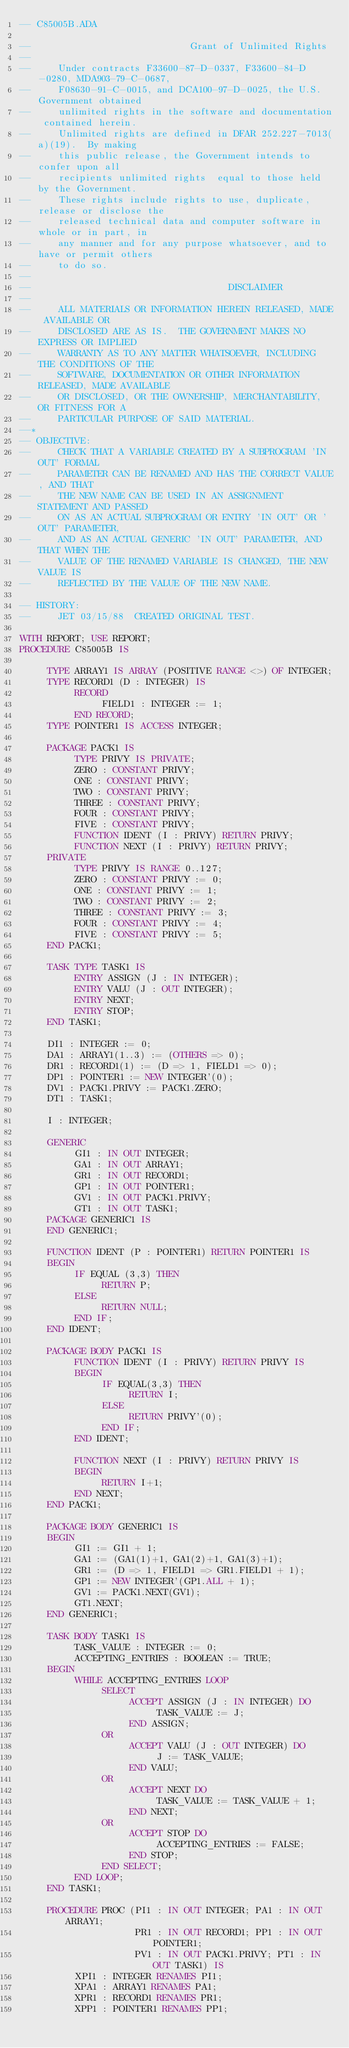Convert code to text. <code><loc_0><loc_0><loc_500><loc_500><_Ada_>-- C85005B.ADA

--                             Grant of Unlimited Rights
--
--     Under contracts F33600-87-D-0337, F33600-84-D-0280, MDA903-79-C-0687,
--     F08630-91-C-0015, and DCA100-97-D-0025, the U.S. Government obtained 
--     unlimited rights in the software and documentation contained herein.
--     Unlimited rights are defined in DFAR 252.227-7013(a)(19).  By making 
--     this public release, the Government intends to confer upon all 
--     recipients unlimited rights  equal to those held by the Government.  
--     These rights include rights to use, duplicate, release or disclose the 
--     released technical data and computer software in whole or in part, in 
--     any manner and for any purpose whatsoever, and to have or permit others 
--     to do so.
--
--                                    DISCLAIMER
--
--     ALL MATERIALS OR INFORMATION HEREIN RELEASED, MADE AVAILABLE OR
--     DISCLOSED ARE AS IS.  THE GOVERNMENT MAKES NO EXPRESS OR IMPLIED 
--     WARRANTY AS TO ANY MATTER WHATSOEVER, INCLUDING THE CONDITIONS OF THE
--     SOFTWARE, DOCUMENTATION OR OTHER INFORMATION RELEASED, MADE AVAILABLE 
--     OR DISCLOSED, OR THE OWNERSHIP, MERCHANTABILITY, OR FITNESS FOR A
--     PARTICULAR PURPOSE OF SAID MATERIAL.
--*
-- OBJECTIVE:
--     CHECK THAT A VARIABLE CREATED BY A SUBPROGRAM 'IN OUT' FORMAL
--     PARAMETER CAN BE RENAMED AND HAS THE CORRECT VALUE, AND THAT
--     THE NEW NAME CAN BE USED IN AN ASSIGNMENT STATEMENT AND PASSED
--     ON AS AN ACTUAL SUBPROGRAM OR ENTRY 'IN OUT' OR 'OUT' PARAMETER,
--     AND AS AN ACTUAL GENERIC 'IN OUT' PARAMETER, AND THAT WHEN THE
--     VALUE OF THE RENAMED VARIABLE IS CHANGED, THE NEW VALUE IS
--     REFLECTED BY THE VALUE OF THE NEW NAME.

-- HISTORY:
--     JET 03/15/88  CREATED ORIGINAL TEST.

WITH REPORT; USE REPORT;
PROCEDURE C85005B IS

     TYPE ARRAY1 IS ARRAY (POSITIVE RANGE <>) OF INTEGER;
     TYPE RECORD1 (D : INTEGER) IS
          RECORD
               FIELD1 : INTEGER := 1;
          END RECORD;
     TYPE POINTER1 IS ACCESS INTEGER;

     PACKAGE PACK1 IS
          TYPE PRIVY IS PRIVATE;
          ZERO : CONSTANT PRIVY;
          ONE : CONSTANT PRIVY;
          TWO : CONSTANT PRIVY;
          THREE : CONSTANT PRIVY;
          FOUR : CONSTANT PRIVY;
          FIVE : CONSTANT PRIVY;
          FUNCTION IDENT (I : PRIVY) RETURN PRIVY;
          FUNCTION NEXT (I : PRIVY) RETURN PRIVY;
     PRIVATE
          TYPE PRIVY IS RANGE 0..127;
          ZERO : CONSTANT PRIVY := 0;
          ONE : CONSTANT PRIVY := 1;
          TWO : CONSTANT PRIVY := 2;
          THREE : CONSTANT PRIVY := 3;
          FOUR : CONSTANT PRIVY := 4;
          FIVE : CONSTANT PRIVY := 5;
     END PACK1;

     TASK TYPE TASK1 IS
          ENTRY ASSIGN (J : IN INTEGER);
          ENTRY VALU (J : OUT INTEGER);
          ENTRY NEXT;
          ENTRY STOP;
     END TASK1;

     DI1 : INTEGER := 0;
     DA1 : ARRAY1(1..3) := (OTHERS => 0);
     DR1 : RECORD1(1) := (D => 1, FIELD1 => 0);
     DP1 : POINTER1 := NEW INTEGER'(0);
     DV1 : PACK1.PRIVY := PACK1.ZERO;
     DT1 : TASK1;

     I : INTEGER;

     GENERIC
          GI1 : IN OUT INTEGER;
          GA1 : IN OUT ARRAY1;
          GR1 : IN OUT RECORD1;
          GP1 : IN OUT POINTER1;
          GV1 : IN OUT PACK1.PRIVY;
          GT1 : IN OUT TASK1;
     PACKAGE GENERIC1 IS
     END GENERIC1;

     FUNCTION IDENT (P : POINTER1) RETURN POINTER1 IS
     BEGIN
          IF EQUAL (3,3) THEN
               RETURN P;
          ELSE
               RETURN NULL;
          END IF;
     END IDENT;

     PACKAGE BODY PACK1 IS
          FUNCTION IDENT (I : PRIVY) RETURN PRIVY IS
          BEGIN
               IF EQUAL(3,3) THEN
                    RETURN I;
               ELSE
                    RETURN PRIVY'(0);
               END IF;
          END IDENT;

          FUNCTION NEXT (I : PRIVY) RETURN PRIVY IS
          BEGIN
               RETURN I+1;
          END NEXT;
     END PACK1;

     PACKAGE BODY GENERIC1 IS
     BEGIN
          GI1 := GI1 + 1;
          GA1 := (GA1(1)+1, GA1(2)+1, GA1(3)+1);
          GR1 := (D => 1, FIELD1 => GR1.FIELD1 + 1);
          GP1 := NEW INTEGER'(GP1.ALL + 1);
          GV1 := PACK1.NEXT(GV1);
          GT1.NEXT;
     END GENERIC1;

     TASK BODY TASK1 IS
          TASK_VALUE : INTEGER := 0;
          ACCEPTING_ENTRIES : BOOLEAN := TRUE;
     BEGIN
          WHILE ACCEPTING_ENTRIES LOOP
               SELECT
                    ACCEPT ASSIGN (J : IN INTEGER) DO
                         TASK_VALUE := J;
                    END ASSIGN;
               OR
                    ACCEPT VALU (J : OUT INTEGER) DO
                         J := TASK_VALUE;
                    END VALU;
               OR
                    ACCEPT NEXT DO
                         TASK_VALUE := TASK_VALUE + 1;
                    END NEXT;
               OR
                    ACCEPT STOP DO
                         ACCEPTING_ENTRIES := FALSE;
                    END STOP;
               END SELECT;
          END LOOP;
     END TASK1;

     PROCEDURE PROC (PI1 : IN OUT INTEGER; PA1 : IN OUT ARRAY1;
                     PR1 : IN OUT RECORD1; PP1 : IN OUT POINTER1;
                     PV1 : IN OUT PACK1.PRIVY; PT1 : IN OUT TASK1) IS
          XPI1 : INTEGER RENAMES PI1;
          XPA1 : ARRAY1 RENAMES PA1;
          XPR1 : RECORD1 RENAMES PR1;
          XPP1 : POINTER1 RENAMES PP1;</code> 